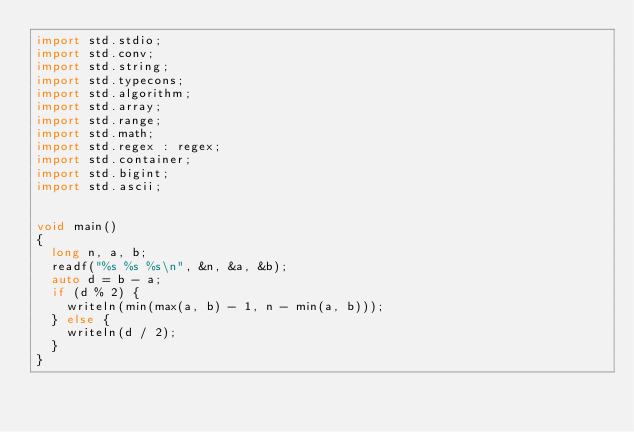<code> <loc_0><loc_0><loc_500><loc_500><_D_>import std.stdio;
import std.conv;
import std.string;
import std.typecons;
import std.algorithm;
import std.array;
import std.range;
import std.math;
import std.regex : regex;
import std.container;
import std.bigint;
import std.ascii;


void main()
{
  long n, a, b;
  readf("%s %s %s\n", &n, &a, &b);
  auto d = b - a;
  if (d % 2) {
    writeln(min(max(a, b) - 1, n - min(a, b)));
  } else {
    writeln(d / 2);
  }
}
</code> 